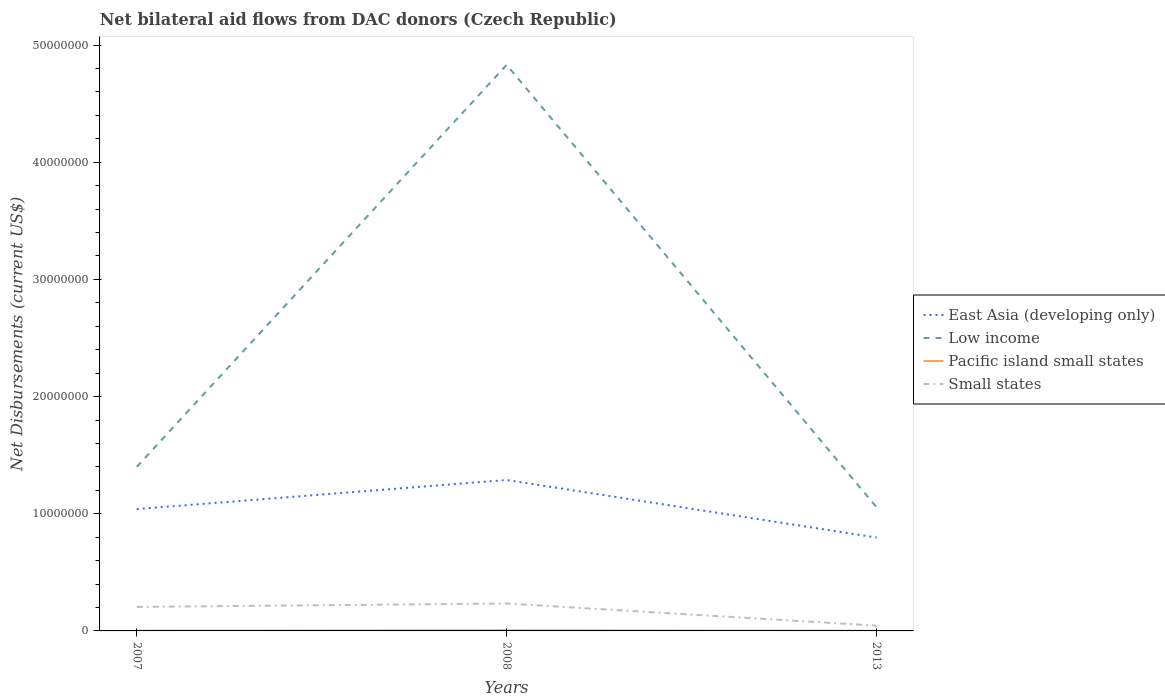Is the number of lines equal to the number of legend labels?
Offer a terse response. Yes. Across all years, what is the maximum net bilateral aid flows in Low income?
Your answer should be very brief. 1.06e+07. What is the total net bilateral aid flows in Small states in the graph?
Offer a terse response. 1.89e+06. What is the difference between the highest and the lowest net bilateral aid flows in Low income?
Keep it short and to the point. 1. Is the net bilateral aid flows in Small states strictly greater than the net bilateral aid flows in East Asia (developing only) over the years?
Keep it short and to the point. Yes. What is the difference between two consecutive major ticks on the Y-axis?
Your answer should be very brief. 1.00e+07. Does the graph contain grids?
Your answer should be very brief. No. Where does the legend appear in the graph?
Your response must be concise. Center right. How are the legend labels stacked?
Your answer should be very brief. Vertical. What is the title of the graph?
Your answer should be compact. Net bilateral aid flows from DAC donors (Czech Republic). Does "Suriname" appear as one of the legend labels in the graph?
Make the answer very short. No. What is the label or title of the Y-axis?
Provide a succinct answer. Net Disbursements (current US$). What is the Net Disbursements (current US$) of East Asia (developing only) in 2007?
Provide a short and direct response. 1.04e+07. What is the Net Disbursements (current US$) in Low income in 2007?
Your answer should be very brief. 1.40e+07. What is the Net Disbursements (current US$) in Pacific island small states in 2007?
Ensure brevity in your answer.  2.00e+04. What is the Net Disbursements (current US$) of Small states in 2007?
Give a very brief answer. 2.05e+06. What is the Net Disbursements (current US$) in East Asia (developing only) in 2008?
Keep it short and to the point. 1.29e+07. What is the Net Disbursements (current US$) in Low income in 2008?
Give a very brief answer. 4.83e+07. What is the Net Disbursements (current US$) of Small states in 2008?
Your response must be concise. 2.34e+06. What is the Net Disbursements (current US$) in East Asia (developing only) in 2013?
Your response must be concise. 7.97e+06. What is the Net Disbursements (current US$) in Low income in 2013?
Make the answer very short. 1.06e+07. Across all years, what is the maximum Net Disbursements (current US$) of East Asia (developing only)?
Keep it short and to the point. 1.29e+07. Across all years, what is the maximum Net Disbursements (current US$) in Low income?
Offer a terse response. 4.83e+07. Across all years, what is the maximum Net Disbursements (current US$) of Small states?
Provide a short and direct response. 2.34e+06. Across all years, what is the minimum Net Disbursements (current US$) in East Asia (developing only)?
Keep it short and to the point. 7.97e+06. Across all years, what is the minimum Net Disbursements (current US$) in Low income?
Your answer should be compact. 1.06e+07. What is the total Net Disbursements (current US$) of East Asia (developing only) in the graph?
Offer a very short reply. 3.12e+07. What is the total Net Disbursements (current US$) of Low income in the graph?
Your response must be concise. 7.29e+07. What is the total Net Disbursements (current US$) in Small states in the graph?
Offer a very short reply. 4.84e+06. What is the difference between the Net Disbursements (current US$) of East Asia (developing only) in 2007 and that in 2008?
Offer a terse response. -2.48e+06. What is the difference between the Net Disbursements (current US$) in Low income in 2007 and that in 2008?
Offer a very short reply. -3.43e+07. What is the difference between the Net Disbursements (current US$) in Small states in 2007 and that in 2008?
Your answer should be compact. -2.90e+05. What is the difference between the Net Disbursements (current US$) in East Asia (developing only) in 2007 and that in 2013?
Offer a terse response. 2.43e+06. What is the difference between the Net Disbursements (current US$) of Low income in 2007 and that in 2013?
Your response must be concise. 3.44e+06. What is the difference between the Net Disbursements (current US$) of Pacific island small states in 2007 and that in 2013?
Provide a short and direct response. 10000. What is the difference between the Net Disbursements (current US$) of Small states in 2007 and that in 2013?
Give a very brief answer. 1.60e+06. What is the difference between the Net Disbursements (current US$) of East Asia (developing only) in 2008 and that in 2013?
Provide a short and direct response. 4.91e+06. What is the difference between the Net Disbursements (current US$) of Low income in 2008 and that in 2013?
Give a very brief answer. 3.78e+07. What is the difference between the Net Disbursements (current US$) in Pacific island small states in 2008 and that in 2013?
Offer a terse response. 5.00e+04. What is the difference between the Net Disbursements (current US$) in Small states in 2008 and that in 2013?
Provide a short and direct response. 1.89e+06. What is the difference between the Net Disbursements (current US$) of East Asia (developing only) in 2007 and the Net Disbursements (current US$) of Low income in 2008?
Offer a very short reply. -3.79e+07. What is the difference between the Net Disbursements (current US$) of East Asia (developing only) in 2007 and the Net Disbursements (current US$) of Pacific island small states in 2008?
Your answer should be very brief. 1.03e+07. What is the difference between the Net Disbursements (current US$) of East Asia (developing only) in 2007 and the Net Disbursements (current US$) of Small states in 2008?
Provide a short and direct response. 8.06e+06. What is the difference between the Net Disbursements (current US$) of Low income in 2007 and the Net Disbursements (current US$) of Pacific island small states in 2008?
Your answer should be compact. 1.39e+07. What is the difference between the Net Disbursements (current US$) of Low income in 2007 and the Net Disbursements (current US$) of Small states in 2008?
Offer a terse response. 1.17e+07. What is the difference between the Net Disbursements (current US$) of Pacific island small states in 2007 and the Net Disbursements (current US$) of Small states in 2008?
Your answer should be very brief. -2.32e+06. What is the difference between the Net Disbursements (current US$) of East Asia (developing only) in 2007 and the Net Disbursements (current US$) of Pacific island small states in 2013?
Your answer should be very brief. 1.04e+07. What is the difference between the Net Disbursements (current US$) in East Asia (developing only) in 2007 and the Net Disbursements (current US$) in Small states in 2013?
Offer a very short reply. 9.95e+06. What is the difference between the Net Disbursements (current US$) in Low income in 2007 and the Net Disbursements (current US$) in Pacific island small states in 2013?
Offer a terse response. 1.40e+07. What is the difference between the Net Disbursements (current US$) of Low income in 2007 and the Net Disbursements (current US$) of Small states in 2013?
Ensure brevity in your answer.  1.36e+07. What is the difference between the Net Disbursements (current US$) of Pacific island small states in 2007 and the Net Disbursements (current US$) of Small states in 2013?
Your response must be concise. -4.30e+05. What is the difference between the Net Disbursements (current US$) of East Asia (developing only) in 2008 and the Net Disbursements (current US$) of Low income in 2013?
Give a very brief answer. 2.32e+06. What is the difference between the Net Disbursements (current US$) of East Asia (developing only) in 2008 and the Net Disbursements (current US$) of Pacific island small states in 2013?
Your answer should be very brief. 1.29e+07. What is the difference between the Net Disbursements (current US$) of East Asia (developing only) in 2008 and the Net Disbursements (current US$) of Small states in 2013?
Your answer should be compact. 1.24e+07. What is the difference between the Net Disbursements (current US$) of Low income in 2008 and the Net Disbursements (current US$) of Pacific island small states in 2013?
Make the answer very short. 4.83e+07. What is the difference between the Net Disbursements (current US$) in Low income in 2008 and the Net Disbursements (current US$) in Small states in 2013?
Ensure brevity in your answer.  4.79e+07. What is the difference between the Net Disbursements (current US$) in Pacific island small states in 2008 and the Net Disbursements (current US$) in Small states in 2013?
Your answer should be very brief. -3.90e+05. What is the average Net Disbursements (current US$) of East Asia (developing only) per year?
Your response must be concise. 1.04e+07. What is the average Net Disbursements (current US$) in Low income per year?
Provide a short and direct response. 2.43e+07. What is the average Net Disbursements (current US$) of Small states per year?
Keep it short and to the point. 1.61e+06. In the year 2007, what is the difference between the Net Disbursements (current US$) in East Asia (developing only) and Net Disbursements (current US$) in Low income?
Ensure brevity in your answer.  -3.60e+06. In the year 2007, what is the difference between the Net Disbursements (current US$) of East Asia (developing only) and Net Disbursements (current US$) of Pacific island small states?
Provide a succinct answer. 1.04e+07. In the year 2007, what is the difference between the Net Disbursements (current US$) of East Asia (developing only) and Net Disbursements (current US$) of Small states?
Your response must be concise. 8.35e+06. In the year 2007, what is the difference between the Net Disbursements (current US$) in Low income and Net Disbursements (current US$) in Pacific island small states?
Provide a short and direct response. 1.40e+07. In the year 2007, what is the difference between the Net Disbursements (current US$) of Low income and Net Disbursements (current US$) of Small states?
Make the answer very short. 1.20e+07. In the year 2007, what is the difference between the Net Disbursements (current US$) of Pacific island small states and Net Disbursements (current US$) of Small states?
Provide a succinct answer. -2.03e+06. In the year 2008, what is the difference between the Net Disbursements (current US$) of East Asia (developing only) and Net Disbursements (current US$) of Low income?
Your response must be concise. -3.54e+07. In the year 2008, what is the difference between the Net Disbursements (current US$) of East Asia (developing only) and Net Disbursements (current US$) of Pacific island small states?
Provide a succinct answer. 1.28e+07. In the year 2008, what is the difference between the Net Disbursements (current US$) of East Asia (developing only) and Net Disbursements (current US$) of Small states?
Your answer should be very brief. 1.05e+07. In the year 2008, what is the difference between the Net Disbursements (current US$) of Low income and Net Disbursements (current US$) of Pacific island small states?
Keep it short and to the point. 4.82e+07. In the year 2008, what is the difference between the Net Disbursements (current US$) in Low income and Net Disbursements (current US$) in Small states?
Make the answer very short. 4.60e+07. In the year 2008, what is the difference between the Net Disbursements (current US$) in Pacific island small states and Net Disbursements (current US$) in Small states?
Your answer should be very brief. -2.28e+06. In the year 2013, what is the difference between the Net Disbursements (current US$) in East Asia (developing only) and Net Disbursements (current US$) in Low income?
Ensure brevity in your answer.  -2.59e+06. In the year 2013, what is the difference between the Net Disbursements (current US$) of East Asia (developing only) and Net Disbursements (current US$) of Pacific island small states?
Provide a succinct answer. 7.96e+06. In the year 2013, what is the difference between the Net Disbursements (current US$) of East Asia (developing only) and Net Disbursements (current US$) of Small states?
Keep it short and to the point. 7.52e+06. In the year 2013, what is the difference between the Net Disbursements (current US$) in Low income and Net Disbursements (current US$) in Pacific island small states?
Give a very brief answer. 1.06e+07. In the year 2013, what is the difference between the Net Disbursements (current US$) of Low income and Net Disbursements (current US$) of Small states?
Offer a terse response. 1.01e+07. In the year 2013, what is the difference between the Net Disbursements (current US$) in Pacific island small states and Net Disbursements (current US$) in Small states?
Your answer should be very brief. -4.40e+05. What is the ratio of the Net Disbursements (current US$) in East Asia (developing only) in 2007 to that in 2008?
Offer a terse response. 0.81. What is the ratio of the Net Disbursements (current US$) of Low income in 2007 to that in 2008?
Your answer should be compact. 0.29. What is the ratio of the Net Disbursements (current US$) in Pacific island small states in 2007 to that in 2008?
Your answer should be very brief. 0.33. What is the ratio of the Net Disbursements (current US$) of Small states in 2007 to that in 2008?
Provide a succinct answer. 0.88. What is the ratio of the Net Disbursements (current US$) of East Asia (developing only) in 2007 to that in 2013?
Make the answer very short. 1.3. What is the ratio of the Net Disbursements (current US$) in Low income in 2007 to that in 2013?
Keep it short and to the point. 1.33. What is the ratio of the Net Disbursements (current US$) of Pacific island small states in 2007 to that in 2013?
Your response must be concise. 2. What is the ratio of the Net Disbursements (current US$) of Small states in 2007 to that in 2013?
Your response must be concise. 4.56. What is the ratio of the Net Disbursements (current US$) of East Asia (developing only) in 2008 to that in 2013?
Ensure brevity in your answer.  1.62. What is the ratio of the Net Disbursements (current US$) of Low income in 2008 to that in 2013?
Make the answer very short. 4.57. What is the ratio of the Net Disbursements (current US$) of Pacific island small states in 2008 to that in 2013?
Provide a succinct answer. 6. What is the ratio of the Net Disbursements (current US$) of Small states in 2008 to that in 2013?
Provide a short and direct response. 5.2. What is the difference between the highest and the second highest Net Disbursements (current US$) of East Asia (developing only)?
Make the answer very short. 2.48e+06. What is the difference between the highest and the second highest Net Disbursements (current US$) of Low income?
Offer a very short reply. 3.43e+07. What is the difference between the highest and the lowest Net Disbursements (current US$) of East Asia (developing only)?
Offer a terse response. 4.91e+06. What is the difference between the highest and the lowest Net Disbursements (current US$) in Low income?
Your response must be concise. 3.78e+07. What is the difference between the highest and the lowest Net Disbursements (current US$) in Small states?
Make the answer very short. 1.89e+06. 